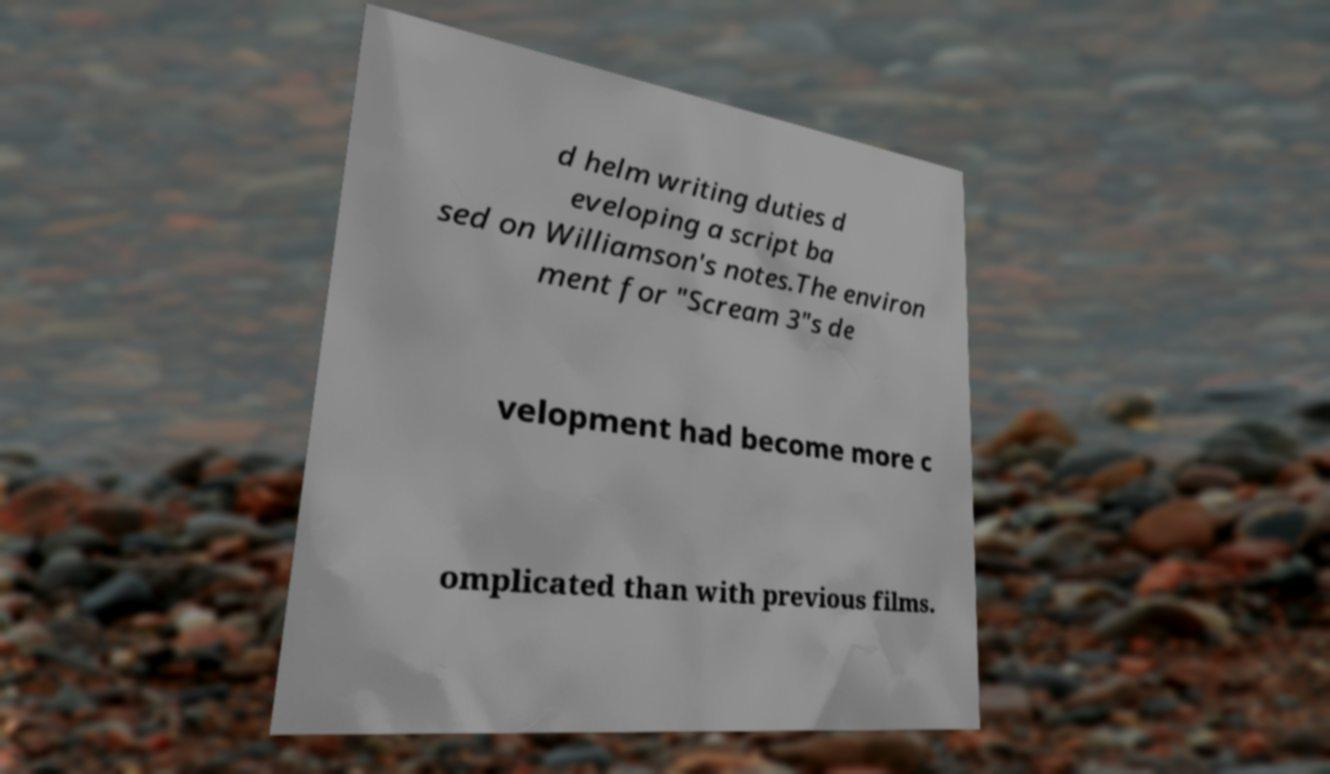Could you extract and type out the text from this image? d helm writing duties d eveloping a script ba sed on Williamson's notes.The environ ment for "Scream 3"s de velopment had become more c omplicated than with previous films. 